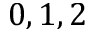Convert formula to latex. <formula><loc_0><loc_0><loc_500><loc_500>0 , 1 , 2</formula> 